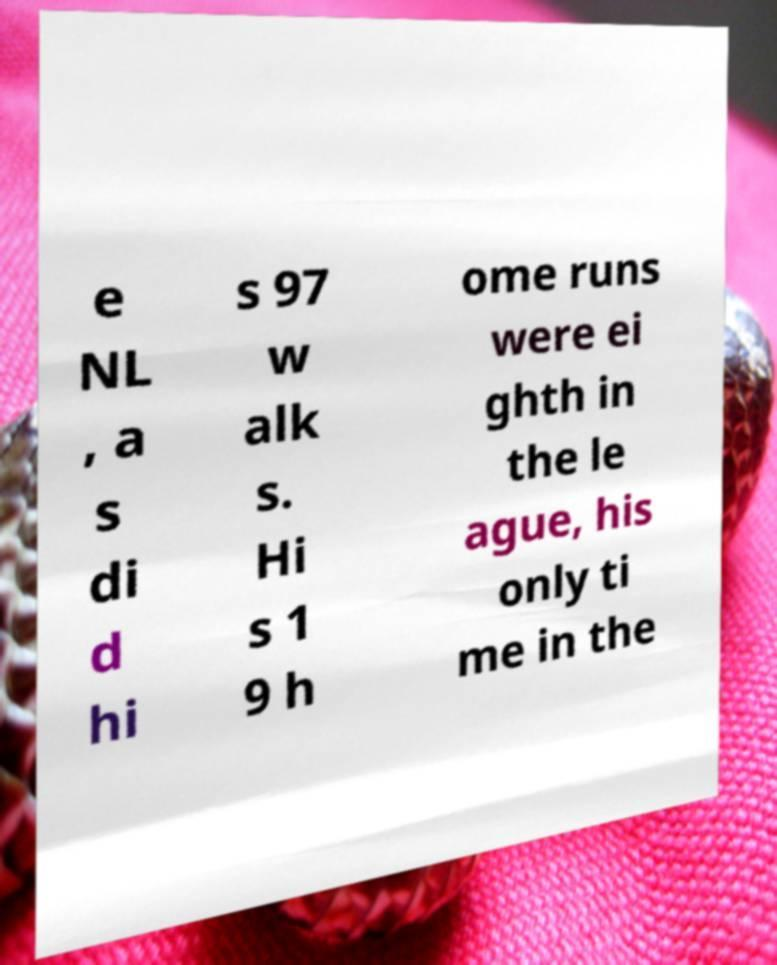For documentation purposes, I need the text within this image transcribed. Could you provide that? e NL , a s di d hi s 97 w alk s. Hi s 1 9 h ome runs were ei ghth in the le ague, his only ti me in the 